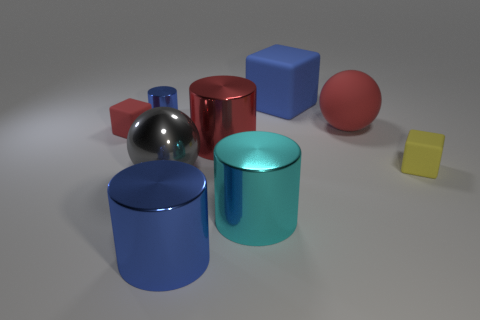What color is the tiny cube that is the same material as the small red object?
Offer a terse response. Yellow. Are there fewer rubber things to the left of the big red rubber object than tiny red blocks that are on the left side of the small shiny thing?
Your response must be concise. No. Do the small block that is to the left of the tiny blue metallic object and the ball left of the blue cube have the same color?
Your response must be concise. No. There is a red matte thing that is right of the blue cylinder in front of the large red cylinder; what size is it?
Offer a terse response. Large. What number of tiny shiny things are the same color as the large rubber block?
Offer a very short reply. 1. Is the large cyan object the same shape as the small blue object?
Provide a succinct answer. Yes. The red object that is the same shape as the large blue matte thing is what size?
Offer a terse response. Small. Are there more red cylinders behind the red cylinder than large metal things left of the large red sphere?
Provide a short and direct response. No. Are the large gray ball and the red object to the left of the large gray shiny thing made of the same material?
Ensure brevity in your answer.  No. What is the color of the thing that is behind the red ball and left of the blue cube?
Offer a terse response. Blue. 